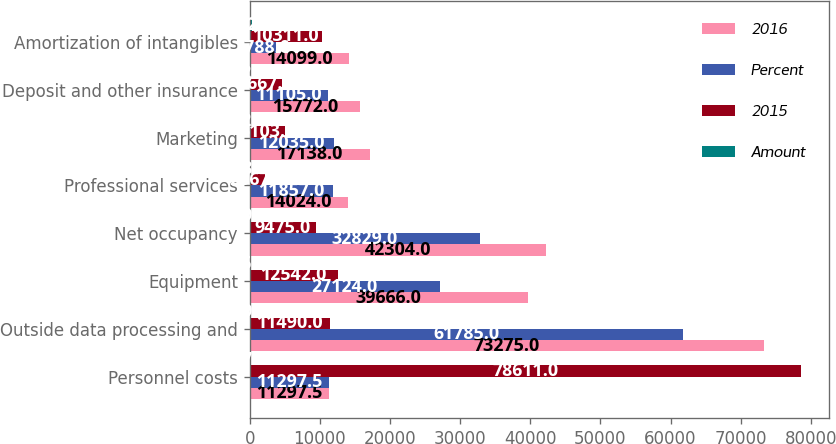<chart> <loc_0><loc_0><loc_500><loc_500><stacked_bar_chart><ecel><fcel>Personnel costs<fcel>Outside data processing and<fcel>Equipment<fcel>Net occupancy<fcel>Professional services<fcel>Marketing<fcel>Deposit and other insurance<fcel>Amortization of intangibles<nl><fcel>2016<fcel>11297.5<fcel>73275<fcel>39666<fcel>42304<fcel>14024<fcel>17138<fcel>15772<fcel>14099<nl><fcel>Percent<fcel>11297.5<fcel>61785<fcel>27124<fcel>32829<fcel>11857<fcel>12035<fcel>11105<fcel>3788<nl><fcel>2015<fcel>78611<fcel>11490<fcel>12542<fcel>9475<fcel>2167<fcel>5103<fcel>4667<fcel>10311<nl><fcel>Amount<fcel>27<fcel>19<fcel>46<fcel>29<fcel>18<fcel>42<fcel>42<fcel>272<nl></chart> 